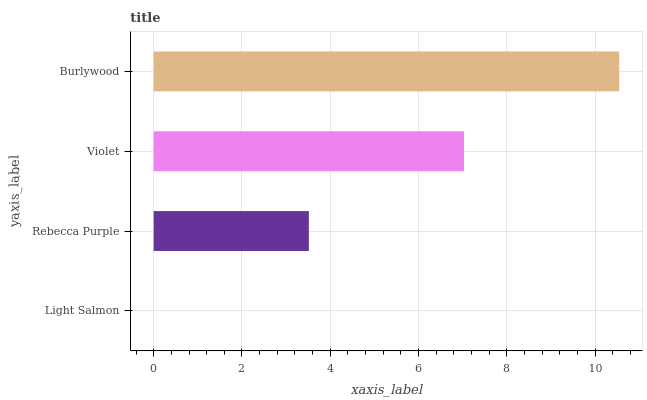Is Light Salmon the minimum?
Answer yes or no. Yes. Is Burlywood the maximum?
Answer yes or no. Yes. Is Rebecca Purple the minimum?
Answer yes or no. No. Is Rebecca Purple the maximum?
Answer yes or no. No. Is Rebecca Purple greater than Light Salmon?
Answer yes or no. Yes. Is Light Salmon less than Rebecca Purple?
Answer yes or no. Yes. Is Light Salmon greater than Rebecca Purple?
Answer yes or no. No. Is Rebecca Purple less than Light Salmon?
Answer yes or no. No. Is Violet the high median?
Answer yes or no. Yes. Is Rebecca Purple the low median?
Answer yes or no. Yes. Is Light Salmon the high median?
Answer yes or no. No. Is Burlywood the low median?
Answer yes or no. No. 